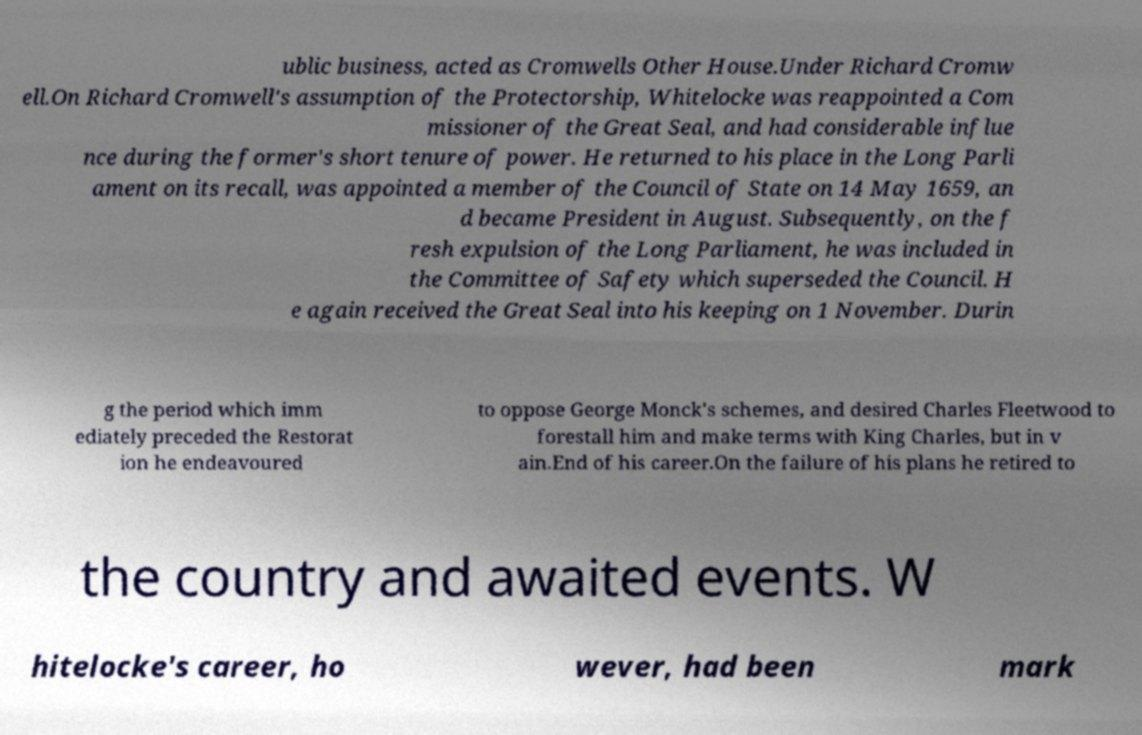Could you assist in decoding the text presented in this image and type it out clearly? ublic business, acted as Cromwells Other House.Under Richard Cromw ell.On Richard Cromwell's assumption of the Protectorship, Whitelocke was reappointed a Com missioner of the Great Seal, and had considerable influe nce during the former's short tenure of power. He returned to his place in the Long Parli ament on its recall, was appointed a member of the Council of State on 14 May 1659, an d became President in August. Subsequently, on the f resh expulsion of the Long Parliament, he was included in the Committee of Safety which superseded the Council. H e again received the Great Seal into his keeping on 1 November. Durin g the period which imm ediately preceded the Restorat ion he endeavoured to oppose George Monck's schemes, and desired Charles Fleetwood to forestall him and make terms with King Charles, but in v ain.End of his career.On the failure of his plans he retired to the country and awaited events. W hitelocke's career, ho wever, had been mark 